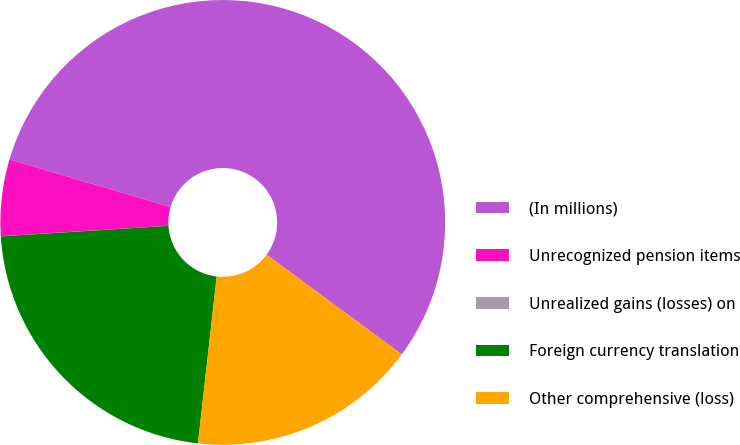Convert chart to OTSL. <chart><loc_0><loc_0><loc_500><loc_500><pie_chart><fcel>(In millions)<fcel>Unrecognized pension items<fcel>Unrealized gains (losses) on<fcel>Foreign currency translation<fcel>Other comprehensive (loss)<nl><fcel>55.54%<fcel>5.56%<fcel>0.01%<fcel>22.22%<fcel>16.67%<nl></chart> 